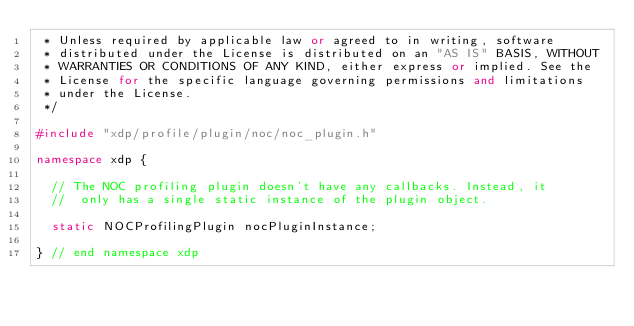<code> <loc_0><loc_0><loc_500><loc_500><_C++_> * Unless required by applicable law or agreed to in writing, software
 * distributed under the License is distributed on an "AS IS" BASIS, WITHOUT
 * WARRANTIES OR CONDITIONS OF ANY KIND, either express or implied. See the
 * License for the specific language governing permissions and limitations
 * under the License.
 */

#include "xdp/profile/plugin/noc/noc_plugin.h"

namespace xdp {

  // The NOC profiling plugin doesn't have any callbacks. Instead, it
  //  only has a single static instance of the plugin object.

  static NOCProfilingPlugin nocPluginInstance;

} // end namespace xdp
</code> 